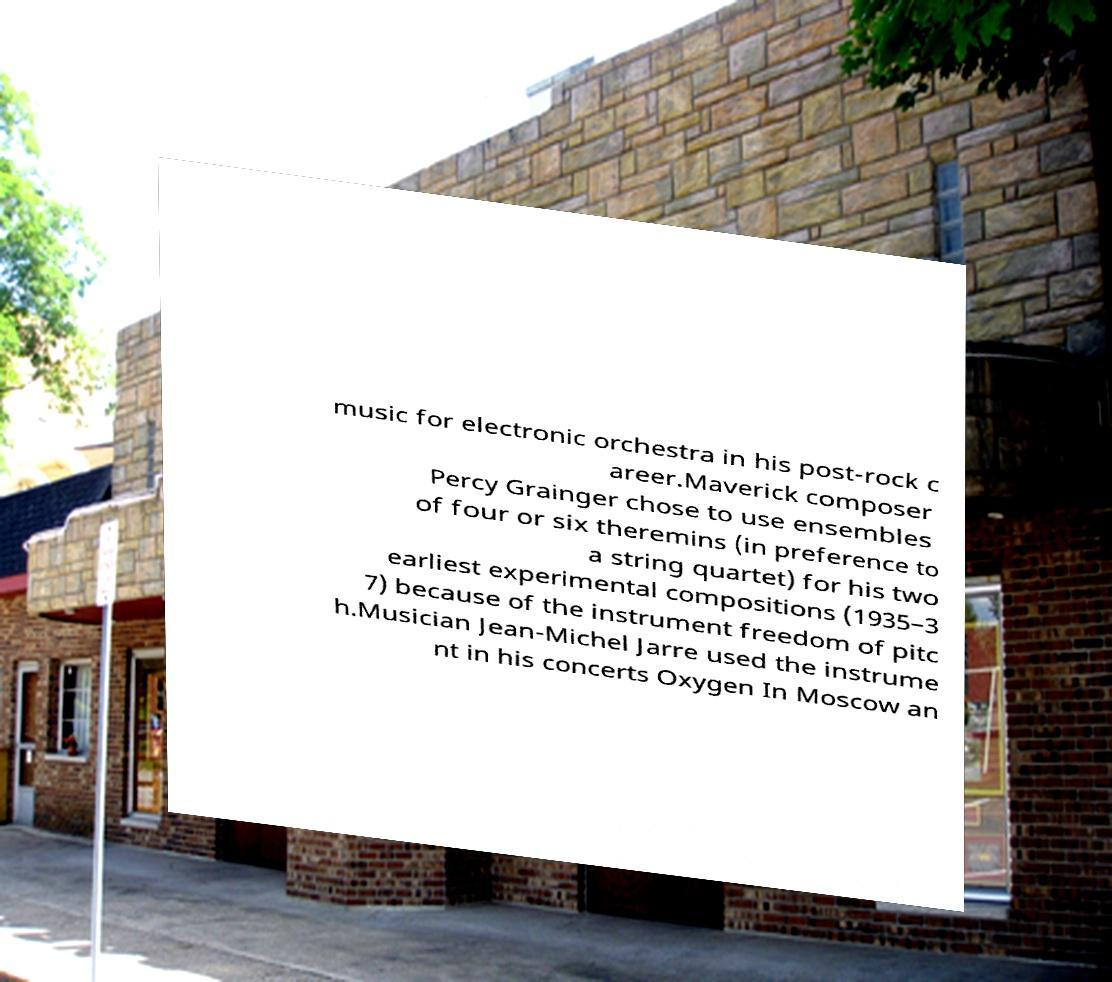Could you extract and type out the text from this image? music for electronic orchestra in his post-rock c areer.Maverick composer Percy Grainger chose to use ensembles of four or six theremins (in preference to a string quartet) for his two earliest experimental compositions (1935–3 7) because of the instrument freedom of pitc h.Musician Jean-Michel Jarre used the instrume nt in his concerts Oxygen In Moscow an 